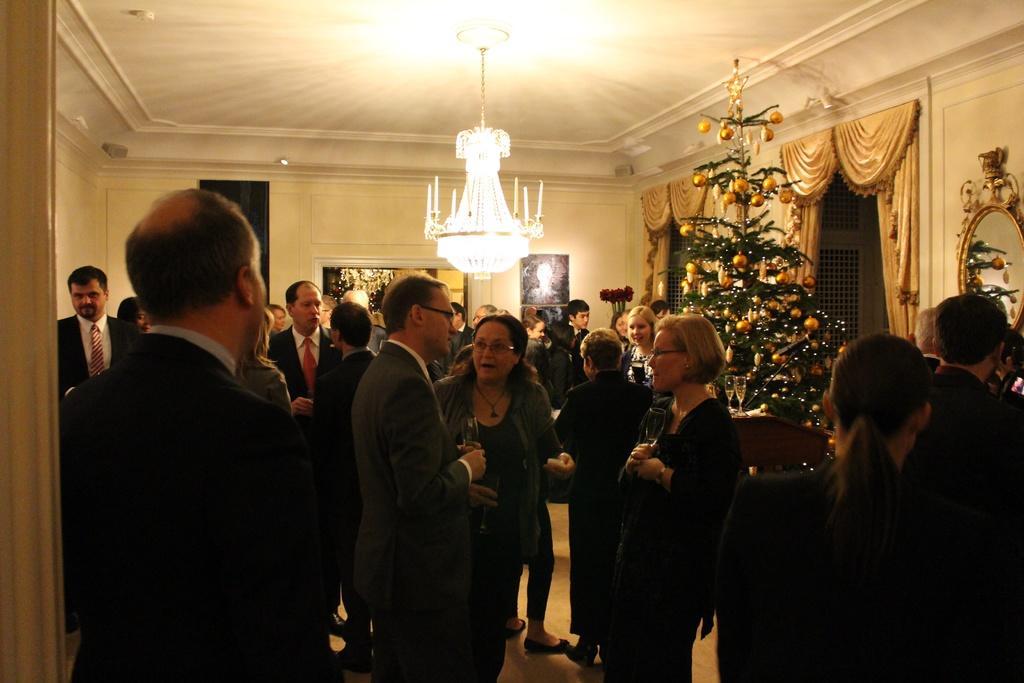In one or two sentences, can you explain what this image depicts? In this image I can see in the middle a group of people are standing and talking together, on the right side there is a Christmas tree, at the top there are lights and there is a mirror on the wall. 